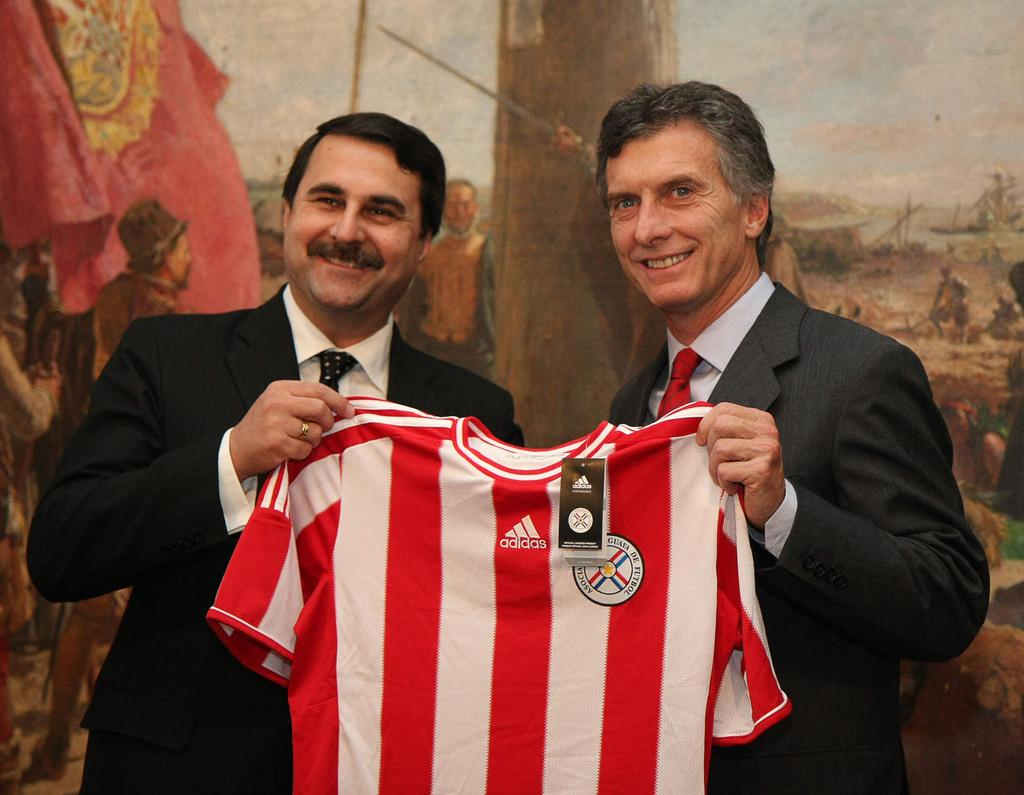Provide a one-sentence caption for the provided image. The red jersey has the ad from Adidas on it. 